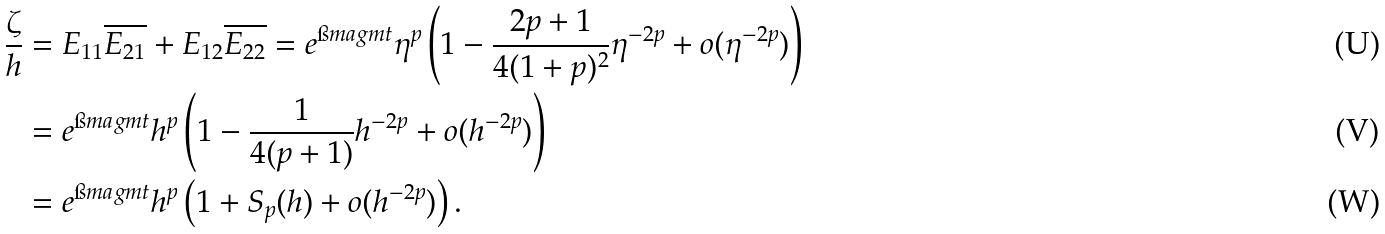Convert formula to latex. <formula><loc_0><loc_0><loc_500><loc_500>\frac { \zeta } { h } & = E _ { 1 1 } \overline { E _ { 2 1 } } + E _ { 1 2 } \overline { E _ { 2 2 } } = e ^ { \i m a g m t } \eta ^ { p } \left ( 1 - \frac { 2 p + 1 } { 4 ( 1 + p ) ^ { 2 } } \eta ^ { - 2 p } + o ( \eta ^ { - 2 p } ) \right ) \\ & = e ^ { \i m a g m t } h ^ { p } \left ( 1 - \frac { 1 } { 4 ( p + 1 ) } h ^ { - 2 p } + o ( h ^ { - 2 p } ) \right ) \\ & = e ^ { \i m a g m t } h ^ { p } \left ( 1 + S _ { p } ( h ) + o ( h ^ { - 2 p } ) \right ) .</formula> 